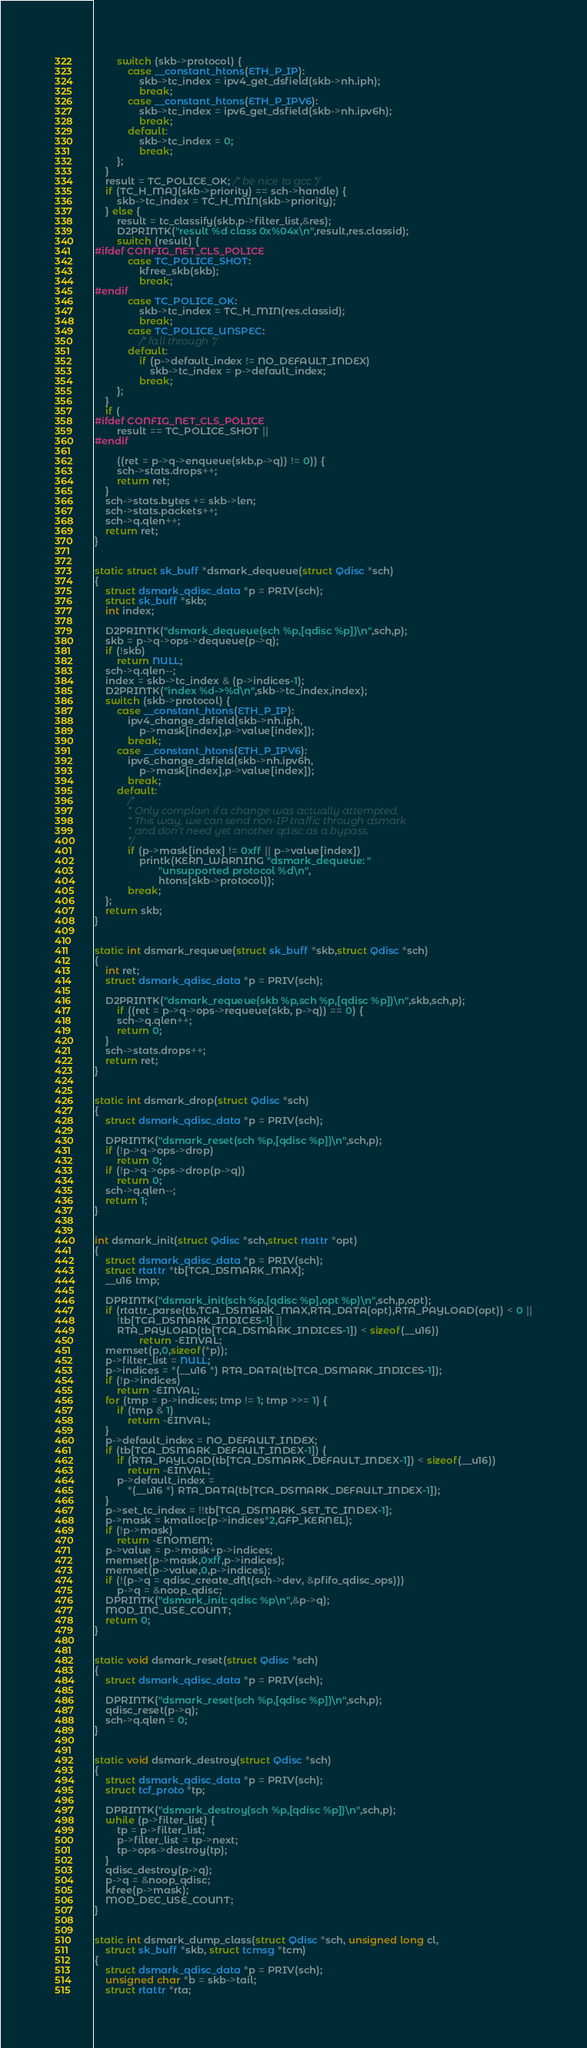Convert code to text. <code><loc_0><loc_0><loc_500><loc_500><_C_>		switch (skb->protocol) {
			case __constant_htons(ETH_P_IP):
				skb->tc_index = ipv4_get_dsfield(skb->nh.iph);
				break;
			case __constant_htons(ETH_P_IPV6):
				skb->tc_index = ipv6_get_dsfield(skb->nh.ipv6h);
				break;
			default:
				skb->tc_index = 0;
				break;
		};
	}
	result = TC_POLICE_OK; /* be nice to gcc */
	if (TC_H_MAJ(skb->priority) == sch->handle) {
		skb->tc_index = TC_H_MIN(skb->priority);
	} else {
		result = tc_classify(skb,p->filter_list,&res);
		D2PRINTK("result %d class 0x%04x\n",result,res.classid);
		switch (result) {
#ifdef CONFIG_NET_CLS_POLICE
			case TC_POLICE_SHOT:
				kfree_skb(skb);
				break;
#endif
			case TC_POLICE_OK:
				skb->tc_index = TC_H_MIN(res.classid);
				break;
			case TC_POLICE_UNSPEC:
				/* fall through */
			default:
				if (p->default_index != NO_DEFAULT_INDEX)
					skb->tc_index = p->default_index;
				break;
		};
	}
	if (
#ifdef CONFIG_NET_CLS_POLICE
	    result == TC_POLICE_SHOT ||
#endif

	    ((ret = p->q->enqueue(skb,p->q)) != 0)) {
		sch->stats.drops++;
		return ret;
	}
	sch->stats.bytes += skb->len;
	sch->stats.packets++;
	sch->q.qlen++;
	return ret;
}


static struct sk_buff *dsmark_dequeue(struct Qdisc *sch)
{
	struct dsmark_qdisc_data *p = PRIV(sch);
	struct sk_buff *skb;
	int index;

	D2PRINTK("dsmark_dequeue(sch %p,[qdisc %p])\n",sch,p);
	skb = p->q->ops->dequeue(p->q);
	if (!skb)
		return NULL;
	sch->q.qlen--;
	index = skb->tc_index & (p->indices-1);
	D2PRINTK("index %d->%d\n",skb->tc_index,index);
	switch (skb->protocol) {
		case __constant_htons(ETH_P_IP):
			ipv4_change_dsfield(skb->nh.iph,
			    p->mask[index],p->value[index]);
			break;
		case __constant_htons(ETH_P_IPV6):
			ipv6_change_dsfield(skb->nh.ipv6h,
			    p->mask[index],p->value[index]);
			break;
		default:
			/*
			 * Only complain if a change was actually attempted.
			 * This way, we can send non-IP traffic through dsmark
			 * and don't need yet another qdisc as a bypass.
			 */
			if (p->mask[index] != 0xff || p->value[index])
				printk(KERN_WARNING "dsmark_dequeue: "
				       "unsupported protocol %d\n",
				       htons(skb->protocol));
			break;
	};
	return skb;
}


static int dsmark_requeue(struct sk_buff *skb,struct Qdisc *sch)
{
	int ret;
	struct dsmark_qdisc_data *p = PRIV(sch);

	D2PRINTK("dsmark_requeue(skb %p,sch %p,[qdisc %p])\n",skb,sch,p);
        if ((ret = p->q->ops->requeue(skb, p->q)) == 0) {
		sch->q.qlen++;
		return 0;
	}
	sch->stats.drops++;
	return ret;
}


static int dsmark_drop(struct Qdisc *sch)
{
	struct dsmark_qdisc_data *p = PRIV(sch);

	DPRINTK("dsmark_reset(sch %p,[qdisc %p])\n",sch,p);
	if (!p->q->ops->drop)
		return 0;
	if (!p->q->ops->drop(p->q))
		return 0;
	sch->q.qlen--;
	return 1;
}


int dsmark_init(struct Qdisc *sch,struct rtattr *opt)
{
	struct dsmark_qdisc_data *p = PRIV(sch);
	struct rtattr *tb[TCA_DSMARK_MAX];
	__u16 tmp;

	DPRINTK("dsmark_init(sch %p,[qdisc %p],opt %p)\n",sch,p,opt);
	if (rtattr_parse(tb,TCA_DSMARK_MAX,RTA_DATA(opt),RTA_PAYLOAD(opt)) < 0 ||
	    !tb[TCA_DSMARK_INDICES-1] ||
	    RTA_PAYLOAD(tb[TCA_DSMARK_INDICES-1]) < sizeof(__u16))
                return -EINVAL;
	memset(p,0,sizeof(*p));
	p->filter_list = NULL;
	p->indices = *(__u16 *) RTA_DATA(tb[TCA_DSMARK_INDICES-1]);
	if (!p->indices)
		return -EINVAL;
	for (tmp = p->indices; tmp != 1; tmp >>= 1) {
		if (tmp & 1)
			return -EINVAL;
	}
	p->default_index = NO_DEFAULT_INDEX;
	if (tb[TCA_DSMARK_DEFAULT_INDEX-1]) {
		if (RTA_PAYLOAD(tb[TCA_DSMARK_DEFAULT_INDEX-1]) < sizeof(__u16))
			return -EINVAL;
		p->default_index =
		    *(__u16 *) RTA_DATA(tb[TCA_DSMARK_DEFAULT_INDEX-1]);
	}
	p->set_tc_index = !!tb[TCA_DSMARK_SET_TC_INDEX-1];
	p->mask = kmalloc(p->indices*2,GFP_KERNEL);
	if (!p->mask)
		return -ENOMEM;
	p->value = p->mask+p->indices;
	memset(p->mask,0xff,p->indices);
	memset(p->value,0,p->indices);
	if (!(p->q = qdisc_create_dflt(sch->dev, &pfifo_qdisc_ops)))
		p->q = &noop_qdisc;
	DPRINTK("dsmark_init: qdisc %p\n",&p->q);
	MOD_INC_USE_COUNT;
	return 0;
}


static void dsmark_reset(struct Qdisc *sch)
{
	struct dsmark_qdisc_data *p = PRIV(sch);

	DPRINTK("dsmark_reset(sch %p,[qdisc %p])\n",sch,p);
	qdisc_reset(p->q);
	sch->q.qlen = 0;
}


static void dsmark_destroy(struct Qdisc *sch)
{
	struct dsmark_qdisc_data *p = PRIV(sch);
	struct tcf_proto *tp;

	DPRINTK("dsmark_destroy(sch %p,[qdisc %p])\n",sch,p);
	while (p->filter_list) {
		tp = p->filter_list;
		p->filter_list = tp->next;
		tp->ops->destroy(tp);
	}
	qdisc_destroy(p->q);
	p->q = &noop_qdisc;
	kfree(p->mask);
	MOD_DEC_USE_COUNT;
}


static int dsmark_dump_class(struct Qdisc *sch, unsigned long cl,
    struct sk_buff *skb, struct tcmsg *tcm)
{
	struct dsmark_qdisc_data *p = PRIV(sch);
	unsigned char *b = skb->tail;
	struct rtattr *rta;
</code> 